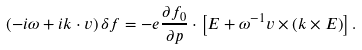<formula> <loc_0><loc_0><loc_500><loc_500>\left ( - i \omega + i { k \cdot v } \right ) \delta f = - e \frac { \partial f _ { 0 } } { \partial { p } } \cdot \left [ { E } + \omega ^ { - 1 } { v \times \left ( k \times E \right ) } \right ] .</formula> 